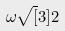<formula> <loc_0><loc_0><loc_500><loc_500>\omega \sqrt { [ } 3 ] { 2 }</formula> 